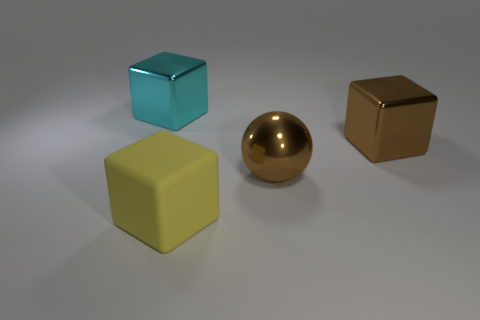Add 4 cyan shiny cubes. How many objects exist? 8 Subtract all yellow cubes. How many cubes are left? 2 Subtract all balls. How many objects are left? 3 Subtract all large shiny blocks. How many blocks are left? 1 Subtract 3 cubes. How many cubes are left? 0 Add 3 big metallic spheres. How many big metallic spheres exist? 4 Subtract 1 cyan blocks. How many objects are left? 3 Subtract all purple cubes. Subtract all cyan cylinders. How many cubes are left? 3 Subtract all green balls. How many yellow cubes are left? 1 Subtract all small gray blocks. Subtract all large cyan objects. How many objects are left? 3 